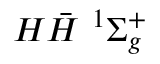Convert formula to latex. <formula><loc_0><loc_0><loc_500><loc_500>{ H } \bar { H } \ ^ { 1 } { \Sigma _ { g } ^ { + } }</formula> 